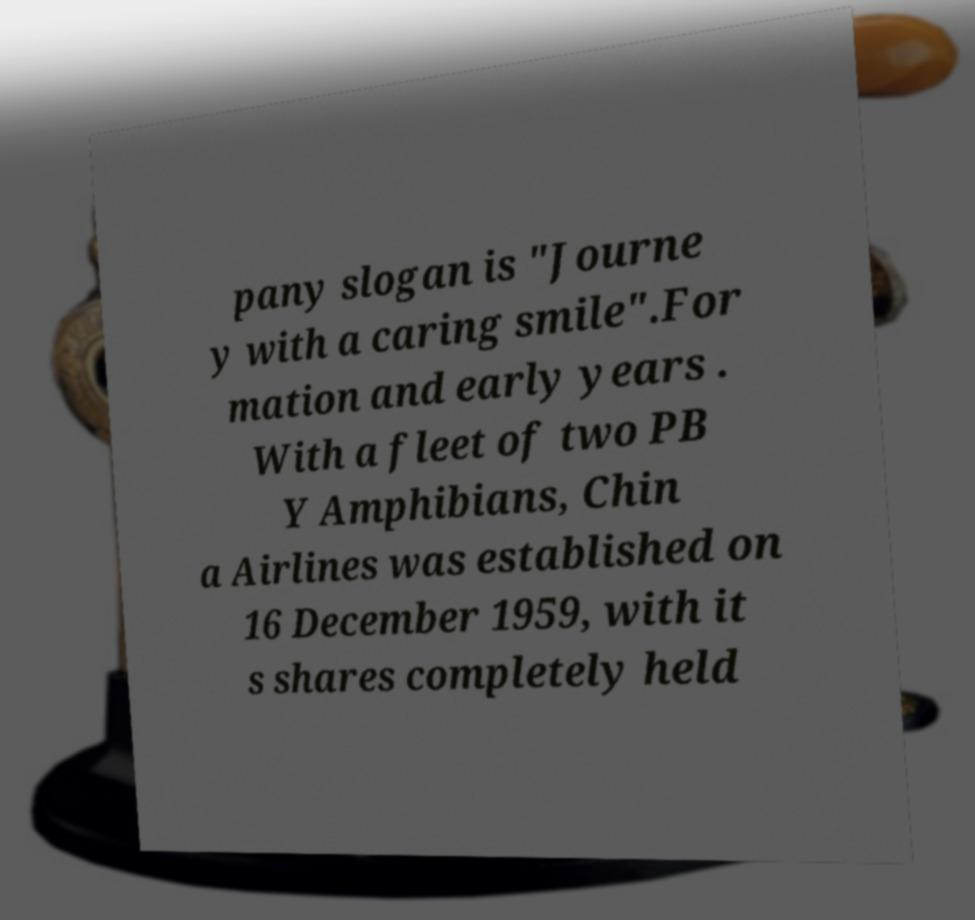For documentation purposes, I need the text within this image transcribed. Could you provide that? pany slogan is "Journe y with a caring smile".For mation and early years . With a fleet of two PB Y Amphibians, Chin a Airlines was established on 16 December 1959, with it s shares completely held 